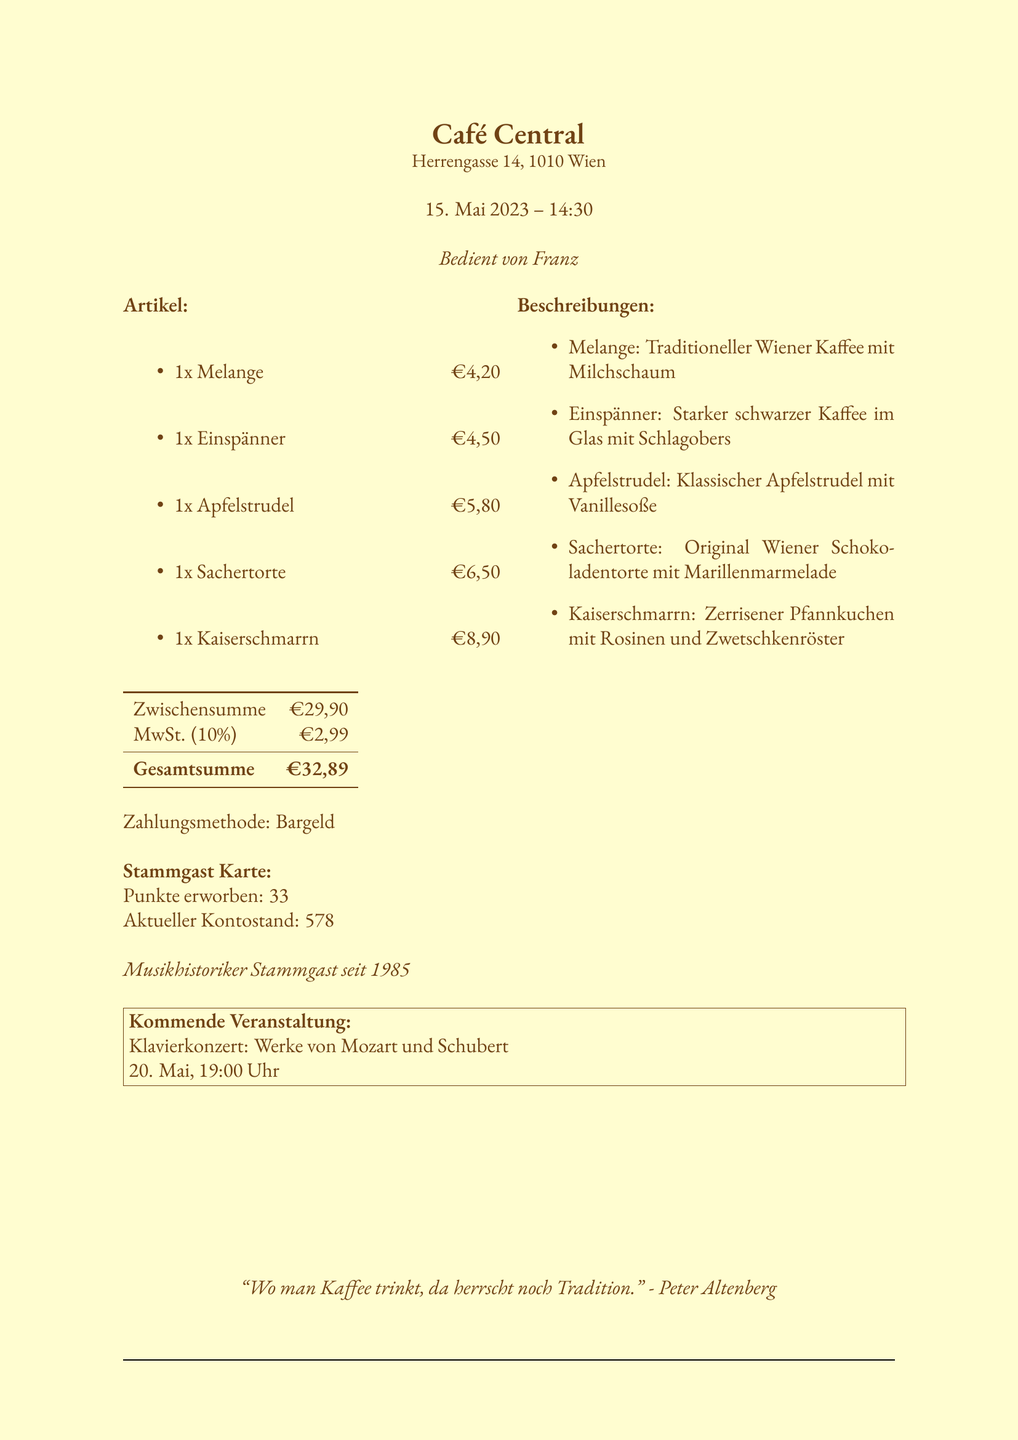What is the name of the café? The name of the café is explicitly stated at the top of the document.
Answer: Café Central What is the address of the café? The address is provided below the café name in the document.
Answer: Herrengasse 14, 1010 Wien What date was the receipt issued? The date of the transaction is indicated in the document under the café information.
Answer: 15. Mai 2023 Who served the coffee? The server's name is mentioned in the document's header.
Answer: Franz What is the total amount charged? The total amount is presented in the summary section of the receipt.
Answer: €32,89 How many points were earned in the loyalty program? Points earned are listed within the loyalty program section of the document.
Answer: 33 What dessert is typically served with vanilla sauce? The document describes a specific dessert with a pairing of vanilla sauce.
Answer: Apfelstrudel What is the upcoming event mentioned in the receipt? The upcoming event is detailed towards the end of the document.
Answer: Klavierkonzert: Werke von Mozart und Schubert What payment method was used? The payment method is clearly stated in the summary of the document.
Answer: Bargeld 